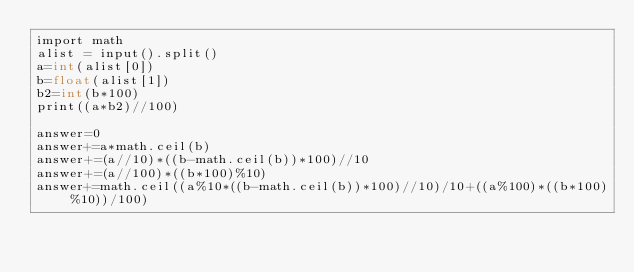<code> <loc_0><loc_0><loc_500><loc_500><_Cython_>import math
alist = input().split()
a=int(alist[0])
b=float(alist[1])
b2=int(b*100)
print((a*b2)//100)

answer=0
answer+=a*math.ceil(b)
answer+=(a//10)*((b-math.ceil(b))*100)//10
answer+=(a//100)*((b*100)%10)
answer+=math.ceil((a%10*((b-math.ceil(b))*100)//10)/10+((a%100)*((b*100)%10))/100)</code> 